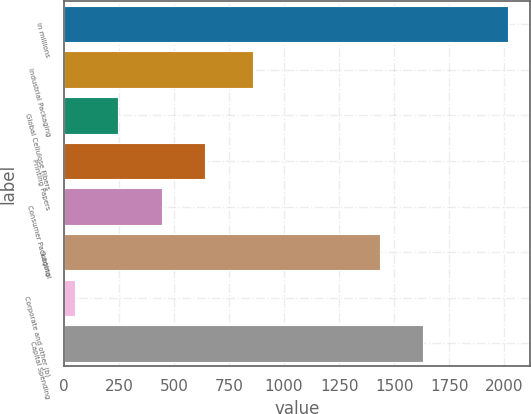Convert chart to OTSL. <chart><loc_0><loc_0><loc_500><loc_500><bar_chart><fcel>In millions<fcel>Industrial Packaging<fcel>Global Cellulose Fibers<fcel>Printing Papers<fcel>Consumer Packaging<fcel>Subtotal<fcel>Corporate and other (b)<fcel>Capital Spending<nl><fcel>2015<fcel>858<fcel>248.3<fcel>640.9<fcel>444.6<fcel>1435<fcel>52<fcel>1631.3<nl></chart> 